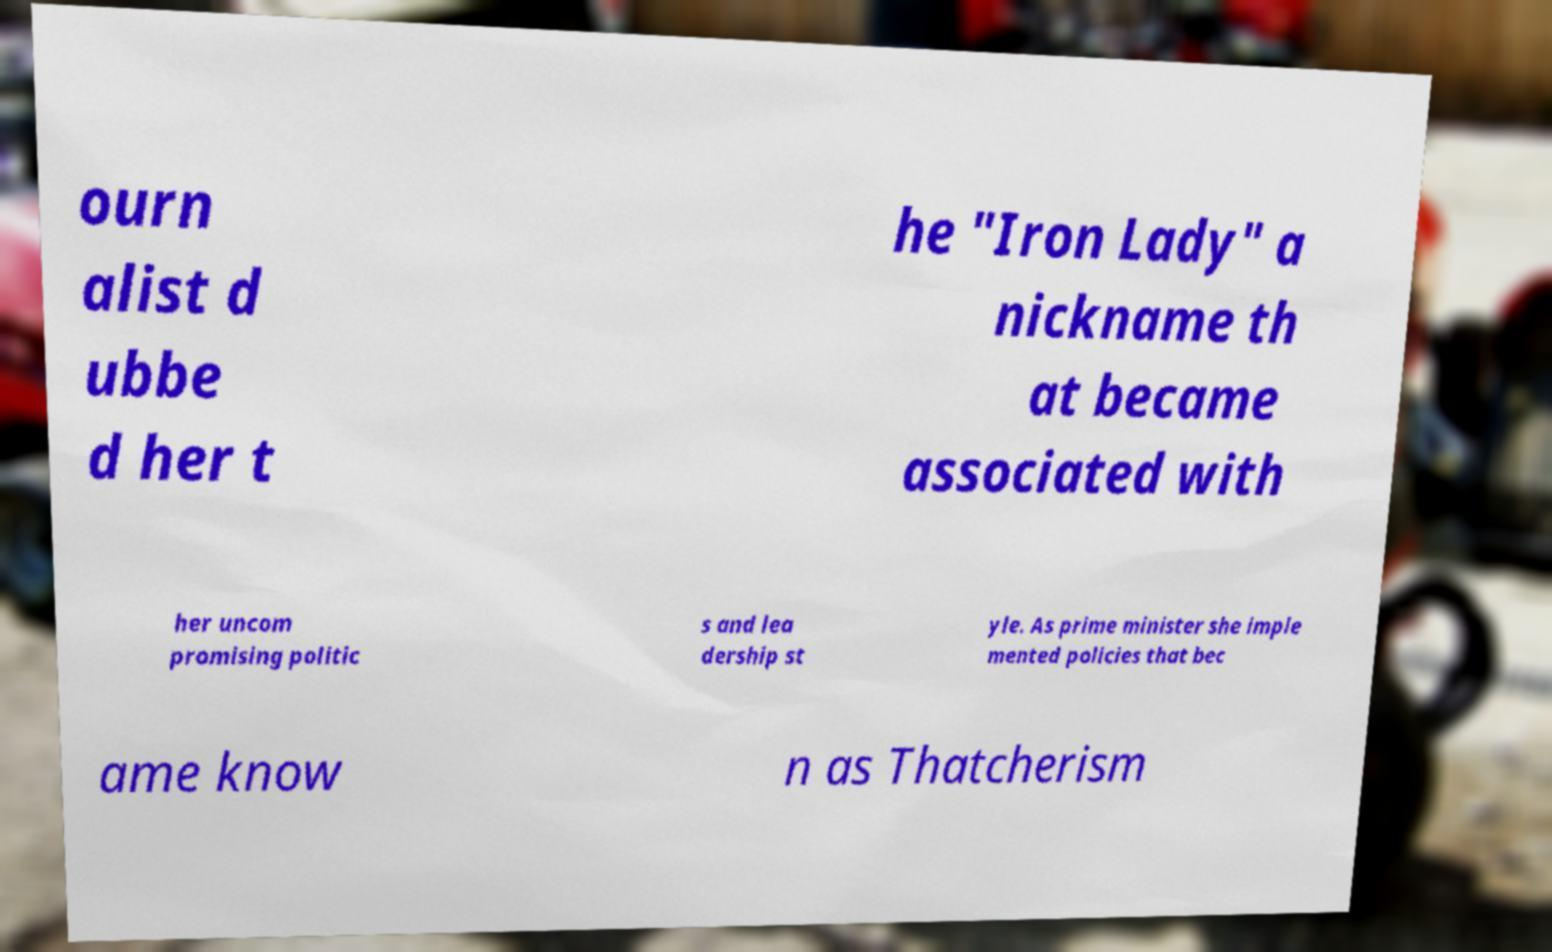Please identify and transcribe the text found in this image. ourn alist d ubbe d her t he "Iron Lady" a nickname th at became associated with her uncom promising politic s and lea dership st yle. As prime minister she imple mented policies that bec ame know n as Thatcherism 